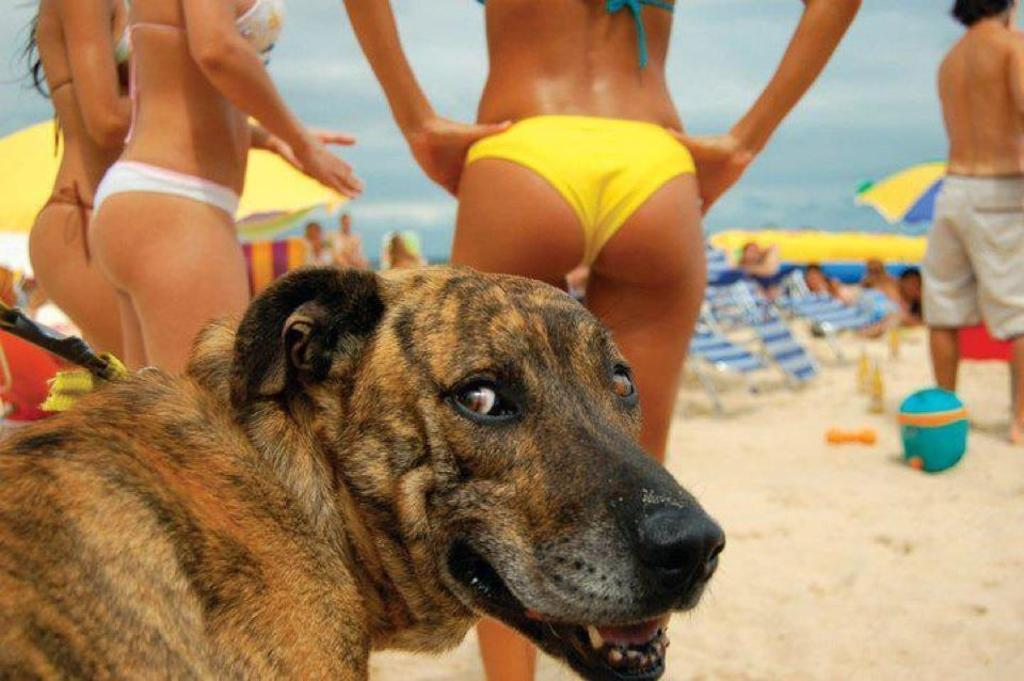What is the main subject in the center of the image? There is a dog in the center of the image. What can be seen in the background of the image? Persons, umbrellas, shacks, water, and sand are present in the background of the image. How many elements can be identified in the background of the image? There are five elements present in the background: persons, umbrellas, shacks, water, and sand. How many worms can be seen crawling on the dog in the image? There are no worms present on the dog in the image. Can you tell me how many flies are buzzing around the persons in the background? There is no mention of flies in the image, so it cannot be determined if any are present. 